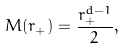Convert formula to latex. <formula><loc_0><loc_0><loc_500><loc_500>M ( r _ { + } ) = \frac { r _ { + } ^ { d - 1 } } { 2 } ,</formula> 